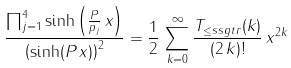Convert formula to latex. <formula><loc_0><loc_0><loc_500><loc_500>\frac { \prod _ { j = 1 } ^ { 4 } \sinh \left ( \frac { P } { p _ { j } } \, x \right ) } { \left ( \sinh ( P \, x ) \right ) ^ { 2 } } = \frac { 1 } { 2 } \, \sum _ { k = 0 } ^ { \infty } \frac { T _ { \leq s s g t r } ( k ) } { ( 2 \, k ) ! } \, x ^ { 2 k }</formula> 